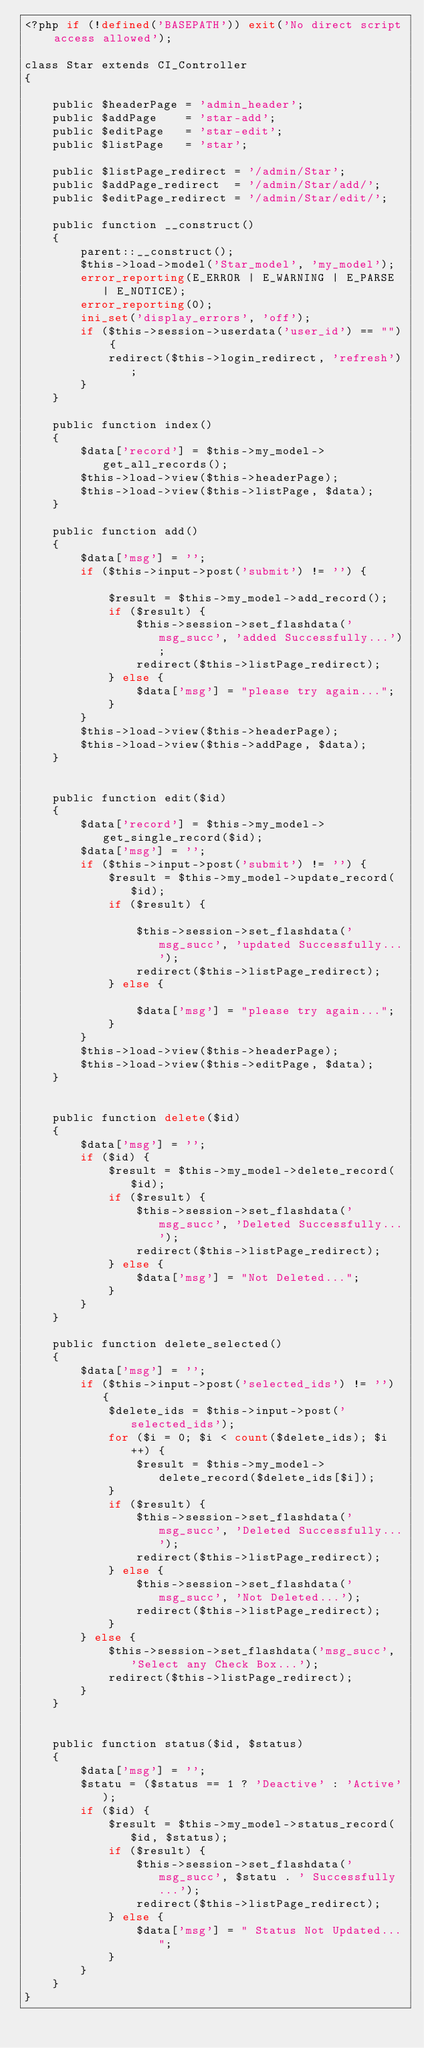Convert code to text. <code><loc_0><loc_0><loc_500><loc_500><_PHP_><?php if (!defined('BASEPATH')) exit('No direct script access allowed');

class Star extends CI_Controller
{

	public $headerPage = 'admin_header';
	public $addPage    = 'star-add';
	public $editPage   = 'star-edit';
	public $listPage   = 'star';

	public $listPage_redirect = '/admin/Star';
	public $addPage_redirect  = '/admin/Star/add/';
	public $editPage_redirect = '/admin/Star/edit/';

	public function __construct()
	{
		parent::__construct();
		$this->load->model('Star_model', 'my_model');
		error_reporting(E_ERROR | E_WARNING | E_PARSE | E_NOTICE);
		error_reporting(0);
		ini_set('display_errors', 'off');
		if ($this->session->userdata('user_id') == "") {
			redirect($this->login_redirect, 'refresh');
		}
	}

	public function index()
	{
		$data['record'] = $this->my_model->get_all_records();
		$this->load->view($this->headerPage);
		$this->load->view($this->listPage, $data);
	}

	public function add()
	{
		$data['msg'] = '';
		if ($this->input->post('submit') != '') {

			$result = $this->my_model->add_record();
			if ($result) {
				$this->session->set_flashdata('msg_succ', 'added Successfully...');
				redirect($this->listPage_redirect);
			} else {
				$data['msg'] = "please try again...";
			}
		}
		$this->load->view($this->headerPage);
		$this->load->view($this->addPage, $data);
	}


	public function edit($id)
	{
		$data['record'] = $this->my_model->get_single_record($id);
		$data['msg'] = '';
		if ($this->input->post('submit') != '') {
			$result = $this->my_model->update_record($id);
			if ($result) {

				$this->session->set_flashdata('msg_succ', 'updated Successfully...');
				redirect($this->listPage_redirect);
			} else {

				$data['msg'] = "please try again...";
			}
		}
		$this->load->view($this->headerPage);
		$this->load->view($this->editPage, $data);
	}


	public function delete($id)
	{
		$data['msg'] = '';
		if ($id) {
			$result = $this->my_model->delete_record($id);
			if ($result) {
				$this->session->set_flashdata('msg_succ', 'Deleted Successfully...');
				redirect($this->listPage_redirect);
			} else {
				$data['msg'] = "Not Deleted...";
			}
		}
	}

	public function delete_selected()
	{
		$data['msg'] = '';
		if ($this->input->post('selected_ids') != '') {
			$delete_ids = $this->input->post('selected_ids');
			for ($i = 0; $i < count($delete_ids); $i++) {
				$result = $this->my_model->delete_record($delete_ids[$i]);
			}
			if ($result) {
				$this->session->set_flashdata('msg_succ', 'Deleted Successfully...');
				redirect($this->listPage_redirect);
			} else {
				$this->session->set_flashdata('msg_succ', 'Not Deleted...');
				redirect($this->listPage_redirect);
			}
		} else {
			$this->session->set_flashdata('msg_succ', 'Select any Check Box...');
			redirect($this->listPage_redirect);
		}
	}


	public function status($id, $status)
	{
		$data['msg'] = '';
		$statu = ($status == 1 ? 'Deactive' : 'Active');
		if ($id) {
			$result = $this->my_model->status_record($id, $status);
			if ($result) {
				$this->session->set_flashdata('msg_succ', $statu . ' Successfully...');
				redirect($this->listPage_redirect);
			} else {
				$data['msg'] = " Status Not Updated...";
			}
		}
	}
}
</code> 